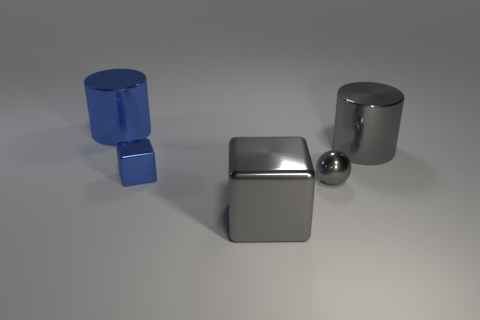Add 2 brown shiny objects. How many objects exist? 7 Subtract 2 blocks. How many blocks are left? 0 Subtract all cylinders. How many objects are left? 3 Subtract all big metal cylinders. Subtract all gray metallic cylinders. How many objects are left? 2 Add 3 small balls. How many small balls are left? 4 Add 2 large gray shiny balls. How many large gray shiny balls exist? 2 Subtract 1 blue cubes. How many objects are left? 4 Subtract all yellow blocks. Subtract all red spheres. How many blocks are left? 2 